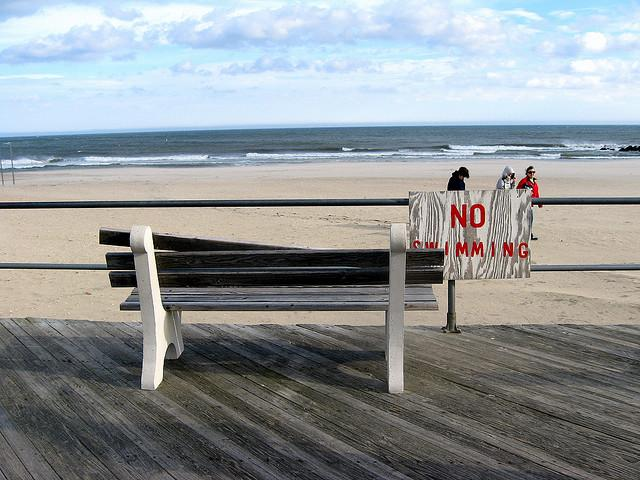What activity does the posted sign advise is not allowed? swimming 